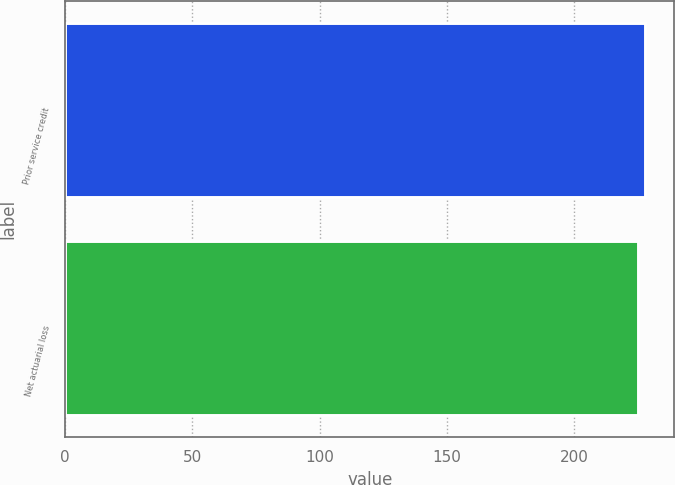Convert chart to OTSL. <chart><loc_0><loc_0><loc_500><loc_500><bar_chart><fcel>Prior service credit<fcel>Net actuarial loss<nl><fcel>228<fcel>225<nl></chart> 